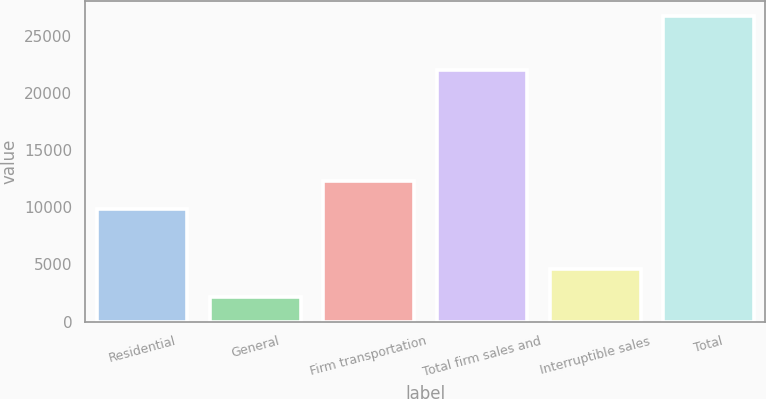Convert chart to OTSL. <chart><loc_0><loc_0><loc_500><loc_500><bar_chart><fcel>Residential<fcel>General<fcel>Firm transportation<fcel>Total firm sales and<fcel>Interruptible sales<fcel>Total<nl><fcel>9860<fcel>2190<fcel>12311.6<fcel>22000<fcel>4641.6<fcel>26706<nl></chart> 